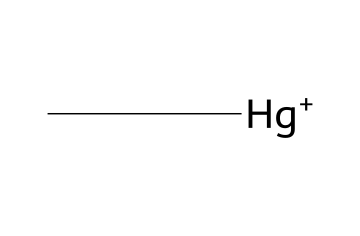What is the molecular formula of this compound? The compound contains one carbon atom (C), one mercury atom (Hg), and no other elements indicated. Therefore, the molecular formula is simply "C1H3Hg" but can be referred to as "CH3Hg".
Answer: CH3Hg How many atoms are present in this molecule? There are a total of two atoms in this molecule: one carbon atom and one mercury atom.
Answer: 2 What type of chemical bonding is present in this compound? This compound consists of a carbon atom bonded to a mercury atom, indicating a covalent bond, which is common in organomercury compounds.
Answer: covalent What is the functional group in methylmercury? Methylmercury has a methyl group (–CH3) attached to mercury, making the methyl group the functional part of the molecule.
Answer: methyl group Is this compound primarily organic or inorganic? Although it contains a metal (mercury), the presence of a carbon atom typically designates it as an organomercury compound, which is considered organic.
Answer: organic What is the charge of the mercury atom in this molecule? The mercury atom in this compound has a positive charge, as indicated by the + sign in the SMILES notation.
Answer: + 